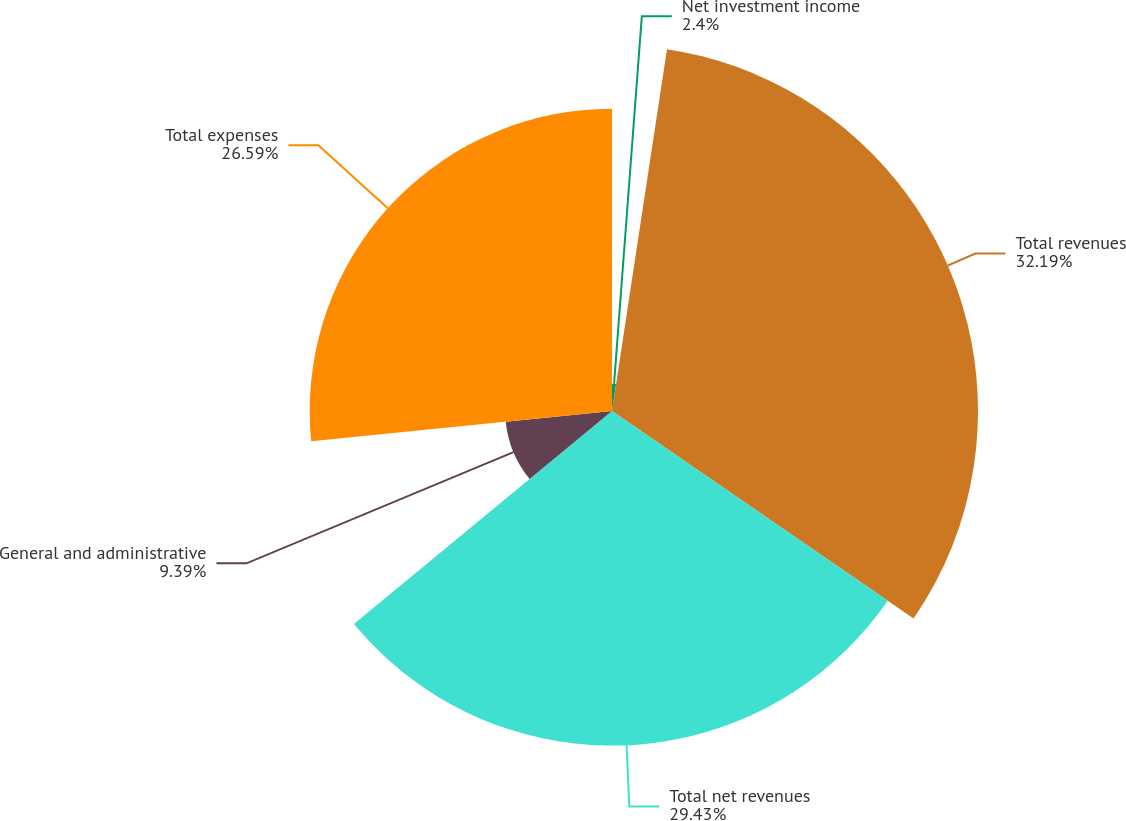Convert chart to OTSL. <chart><loc_0><loc_0><loc_500><loc_500><pie_chart><fcel>Net investment income<fcel>Total revenues<fcel>Total net revenues<fcel>General and administrative<fcel>Total expenses<nl><fcel>2.4%<fcel>32.19%<fcel>29.43%<fcel>9.39%<fcel>26.59%<nl></chart> 